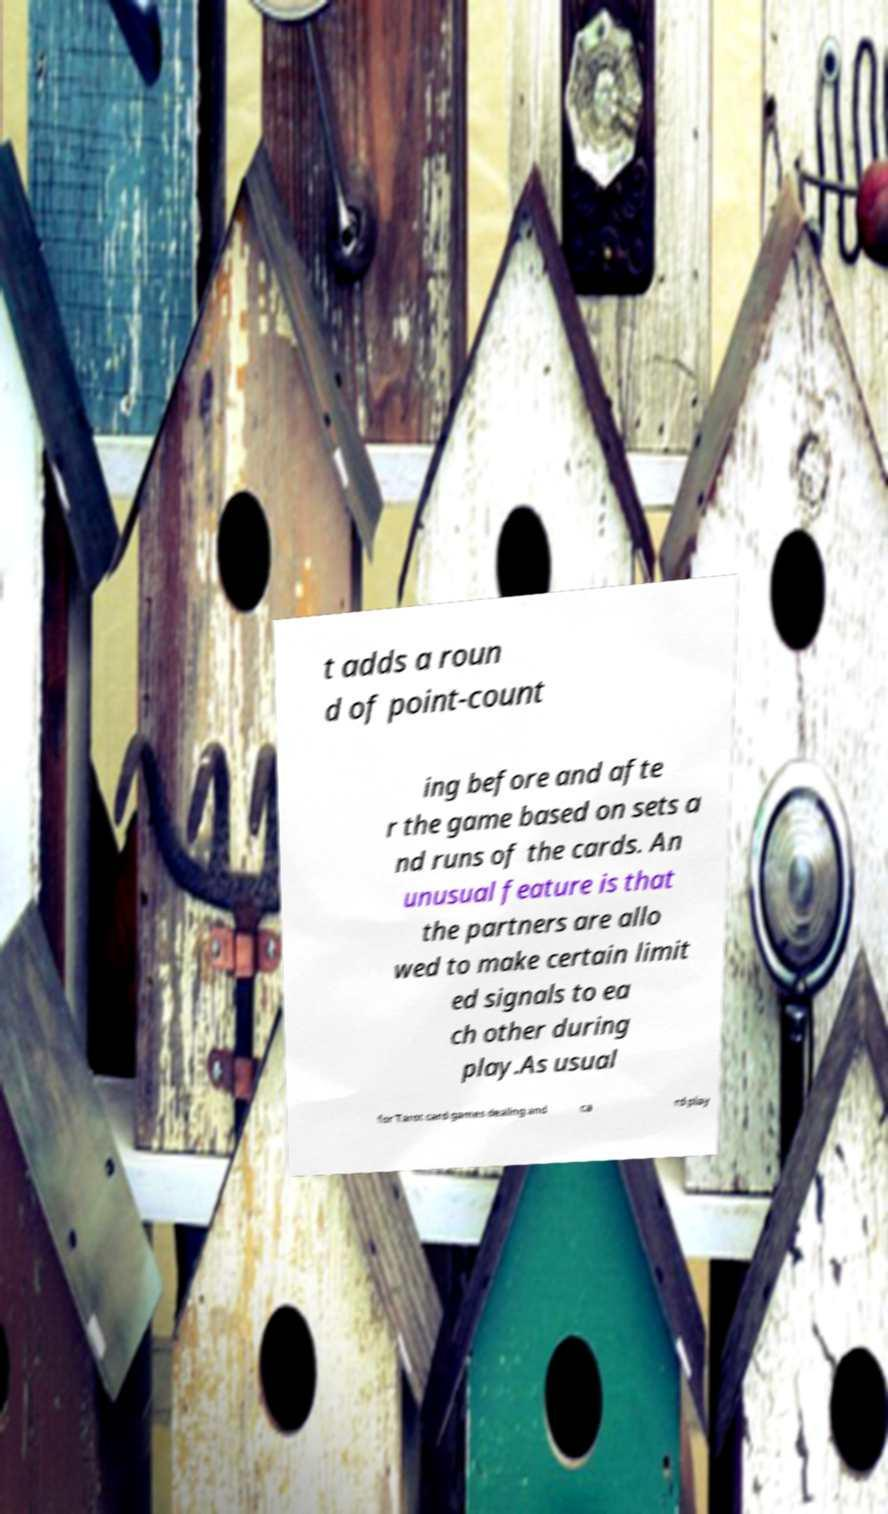Could you assist in decoding the text presented in this image and type it out clearly? t adds a roun d of point-count ing before and afte r the game based on sets a nd runs of the cards. An unusual feature is that the partners are allo wed to make certain limit ed signals to ea ch other during play.As usual for Tarot card games dealing and ca rd play 